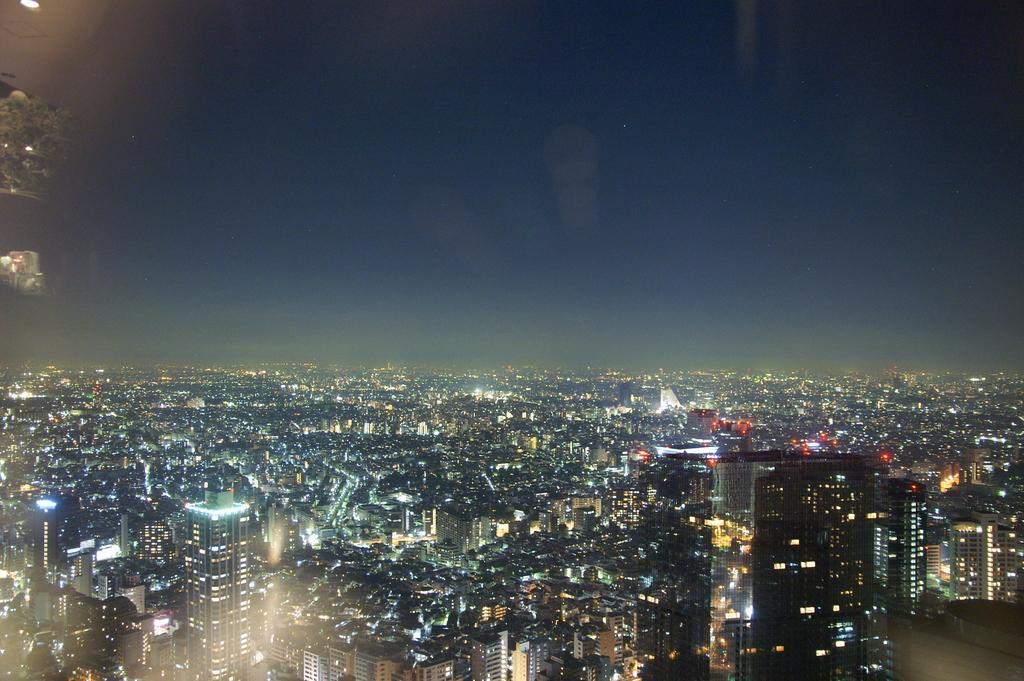What type of structures are present in the image? There are buildings in the image. What can be seen in the background of the image? The sky is visible in the background of the image. Are there any additional features on the buildings? Yes, there are lights on the buildings. What type of ink is being used to write on the yoke in the image? There is no yoke or writing present in the image; it features buildings and lights. 